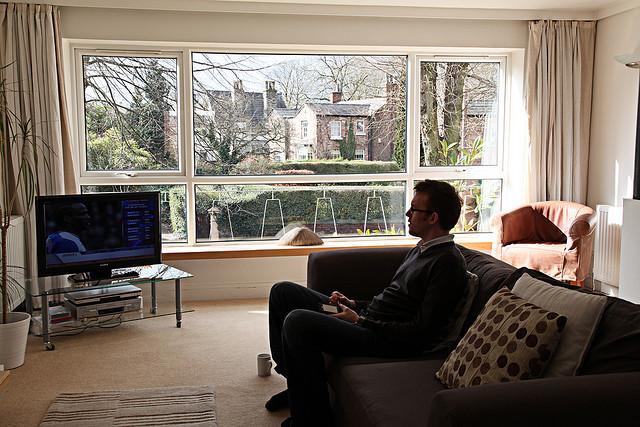How many window panes are there?
Give a very brief answer. 6. How many pillows are there?
Give a very brief answer. 3. Is the TV on?
Answer briefly. Yes. 